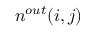<formula> <loc_0><loc_0><loc_500><loc_500>n ^ { o u t } ( i , j )</formula> 